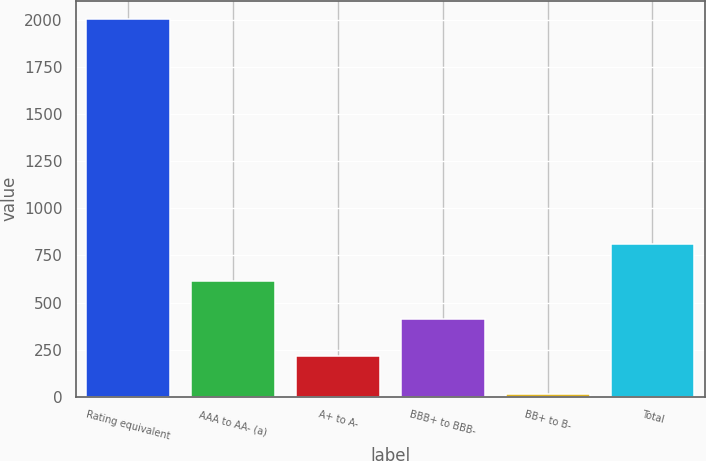Convert chart to OTSL. <chart><loc_0><loc_0><loc_500><loc_500><bar_chart><fcel>Rating equivalent<fcel>AAA to AA- (a)<fcel>A+ to A-<fcel>BBB+ to BBB-<fcel>BB+ to B-<fcel>Total<nl><fcel>2005<fcel>612<fcel>214<fcel>413<fcel>15<fcel>811<nl></chart> 